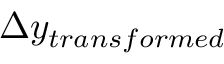Convert formula to latex. <formula><loc_0><loc_0><loc_500><loc_500>\Delta y _ { t r a n s f o r m e d }</formula> 